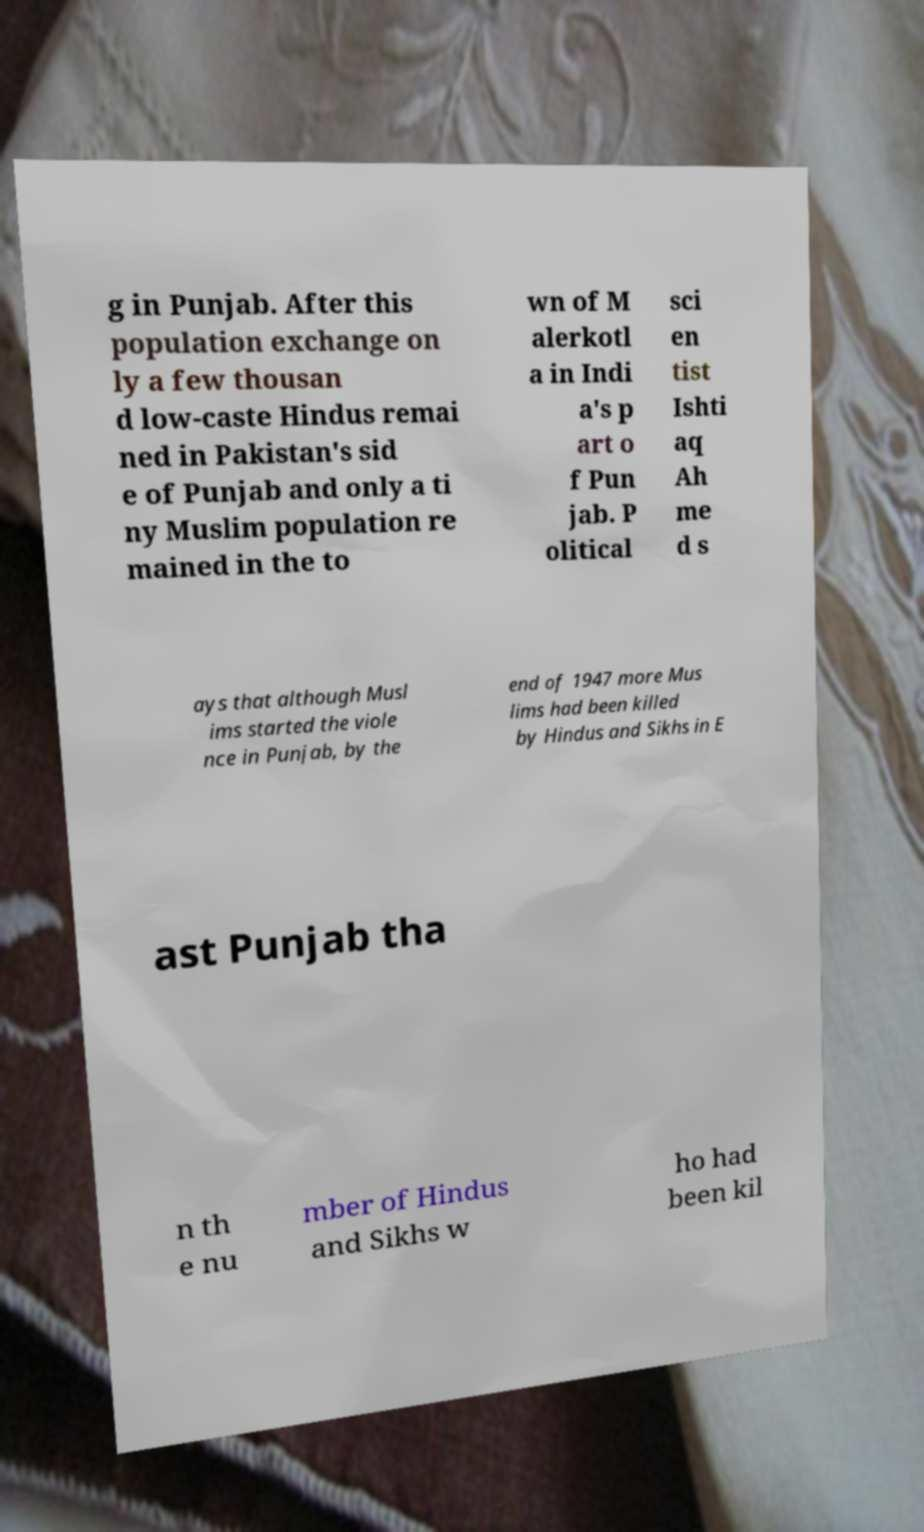For documentation purposes, I need the text within this image transcribed. Could you provide that? g in Punjab. After this population exchange on ly a few thousan d low-caste Hindus remai ned in Pakistan's sid e of Punjab and only a ti ny Muslim population re mained in the to wn of M alerkotl a in Indi a's p art o f Pun jab. P olitical sci en tist Ishti aq Ah me d s ays that although Musl ims started the viole nce in Punjab, by the end of 1947 more Mus lims had been killed by Hindus and Sikhs in E ast Punjab tha n th e nu mber of Hindus and Sikhs w ho had been kil 